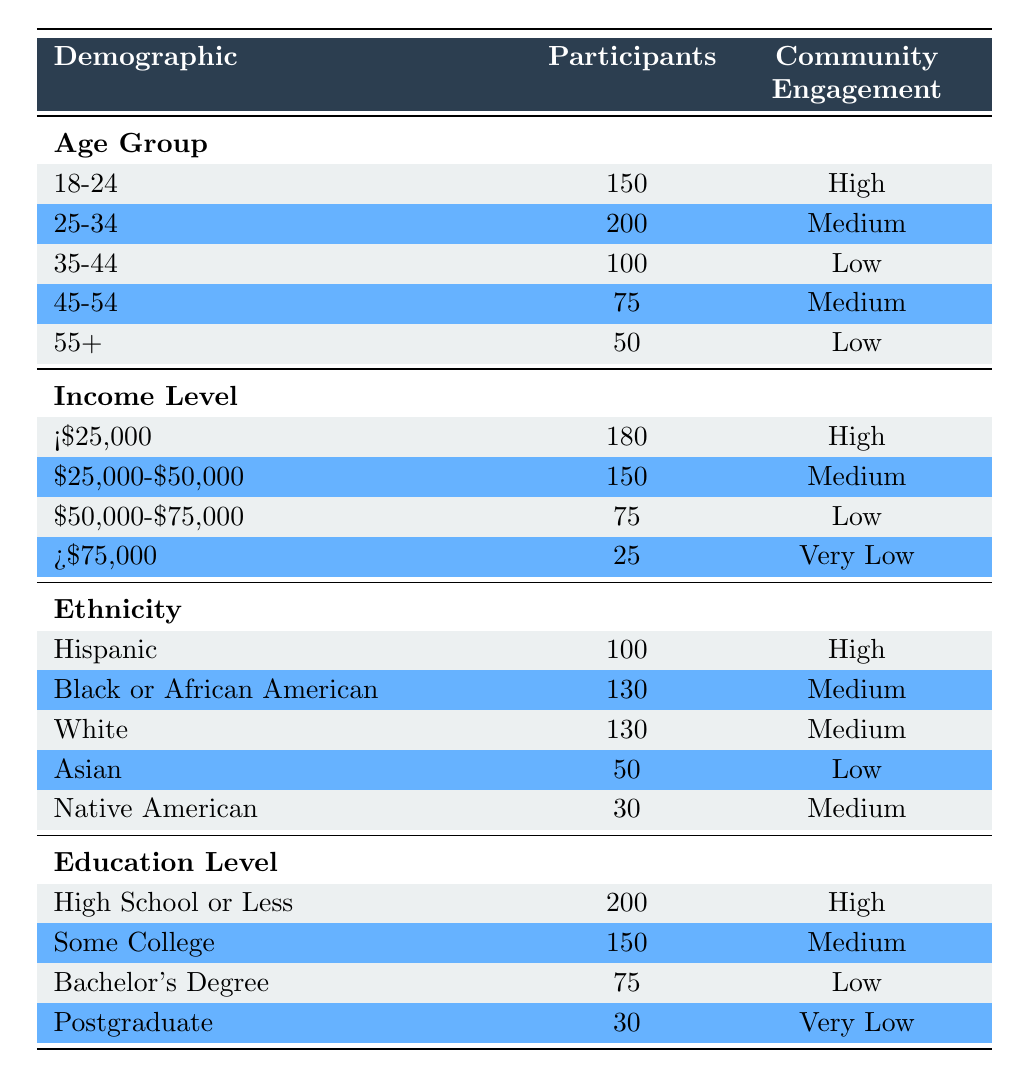What is the community engagement level for the age group 18-24? The table shows that the community engagement level for the age group 18-24 is categorized as "High."
Answer: High How many participants are there in the income bracket of $25,000-$50,000? According to the table, the income bracket of $25,000-$50,000 has 150 participants listed.
Answer: 150 Is the community engagement for participants with a Bachelor's degree low? Yes, the table indicates that community engagement for participants with a Bachelor's degree is categorized as "Low."
Answer: Yes What is the total number of participants in age groups 45-54 and 55+? Adding the participants from these two age groups: 75 (45-54) + 50 (55+) = 125 participants total.
Answer: 125 Which income bracket has the highest community engagement? The table reveals that the income bracket of less than $25,000 has the highest community engagement level, categorized as "High."
Answer: <$25,000 What is the difference in the number of participants between the age groups 25-34 and 35-44? The age group 25-34 has 200 participants and the group 35-44 has 100 participants. The difference is 200 - 100 = 100 participants.
Answer: 100 Are there more participants in the "High School or Less" category compared to the "Postgraduate" category? Yes, the table states that there are 200 participants in the "High School or Less" category and only 30 in the "Postgraduate" category, confirming that there are more in the former.
Answer: Yes What is the average number of participants across the different income levels? The total number of participants across all income levels is 180 + 150 + 75 + 25 = 430. There are 4 income levels, so the average is 430 / 4 = 107.5.
Answer: 107.5 Which ethnicity group had the least number of participants? According to the table, the "Native American" ethnicity group has the least number of participants with 30.
Answer: Native American What is the combined community engagement level for the education levels of "High School or Less" and "Some College"? The engagement levels for these education levels are "High" for "High School or Less" and "Medium" for "Some College." Therefore, the combined community engagement could be said to average out as "High" since the participation is greater in the first category.
Answer: High 